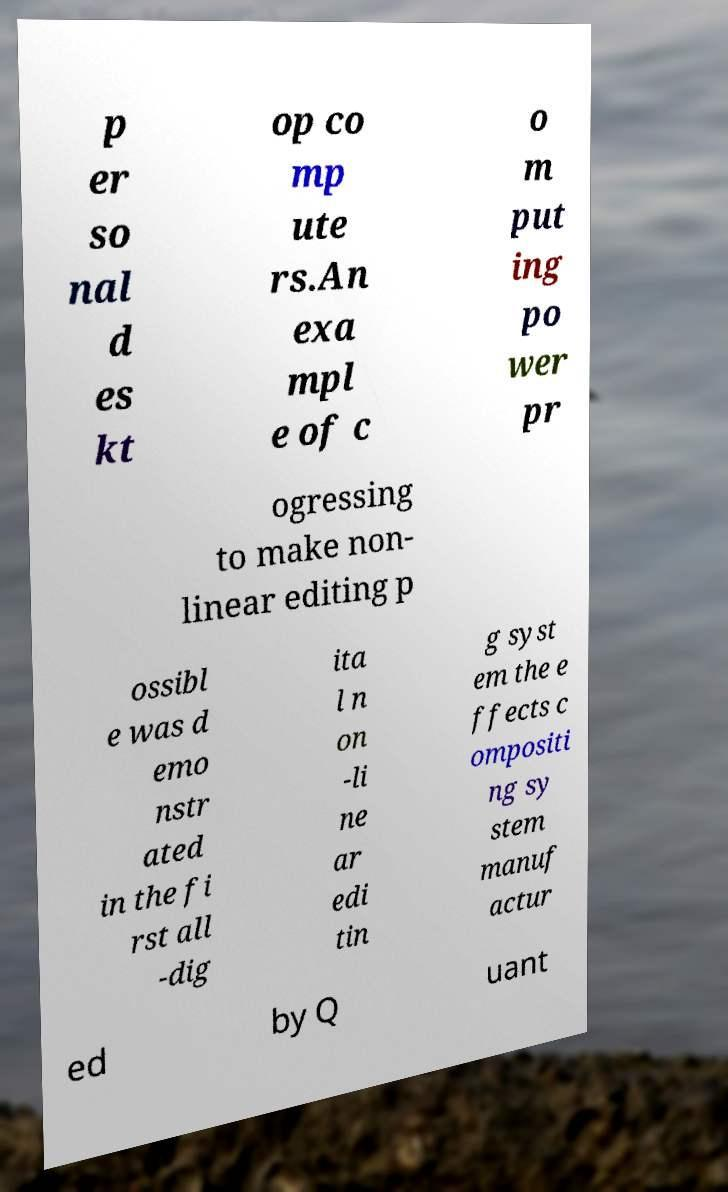Can you read and provide the text displayed in the image?This photo seems to have some interesting text. Can you extract and type it out for me? p er so nal d es kt op co mp ute rs.An exa mpl e of c o m put ing po wer pr ogressing to make non- linear editing p ossibl e was d emo nstr ated in the fi rst all -dig ita l n on -li ne ar edi tin g syst em the e ffects c ompositi ng sy stem manuf actur ed by Q uant 